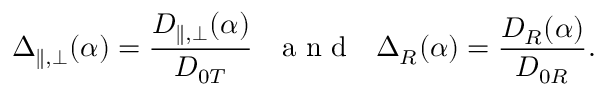<formula> <loc_0><loc_0><loc_500><loc_500>\Delta _ { \| , \perp } ( \alpha ) = \frac { D _ { \| , \perp } ( \alpha ) } { D _ { 0 T } } \, { a n d } \, \Delta _ { R } ( \alpha ) = \frac { D _ { R } ( \alpha ) } { D _ { 0 R } } .</formula> 